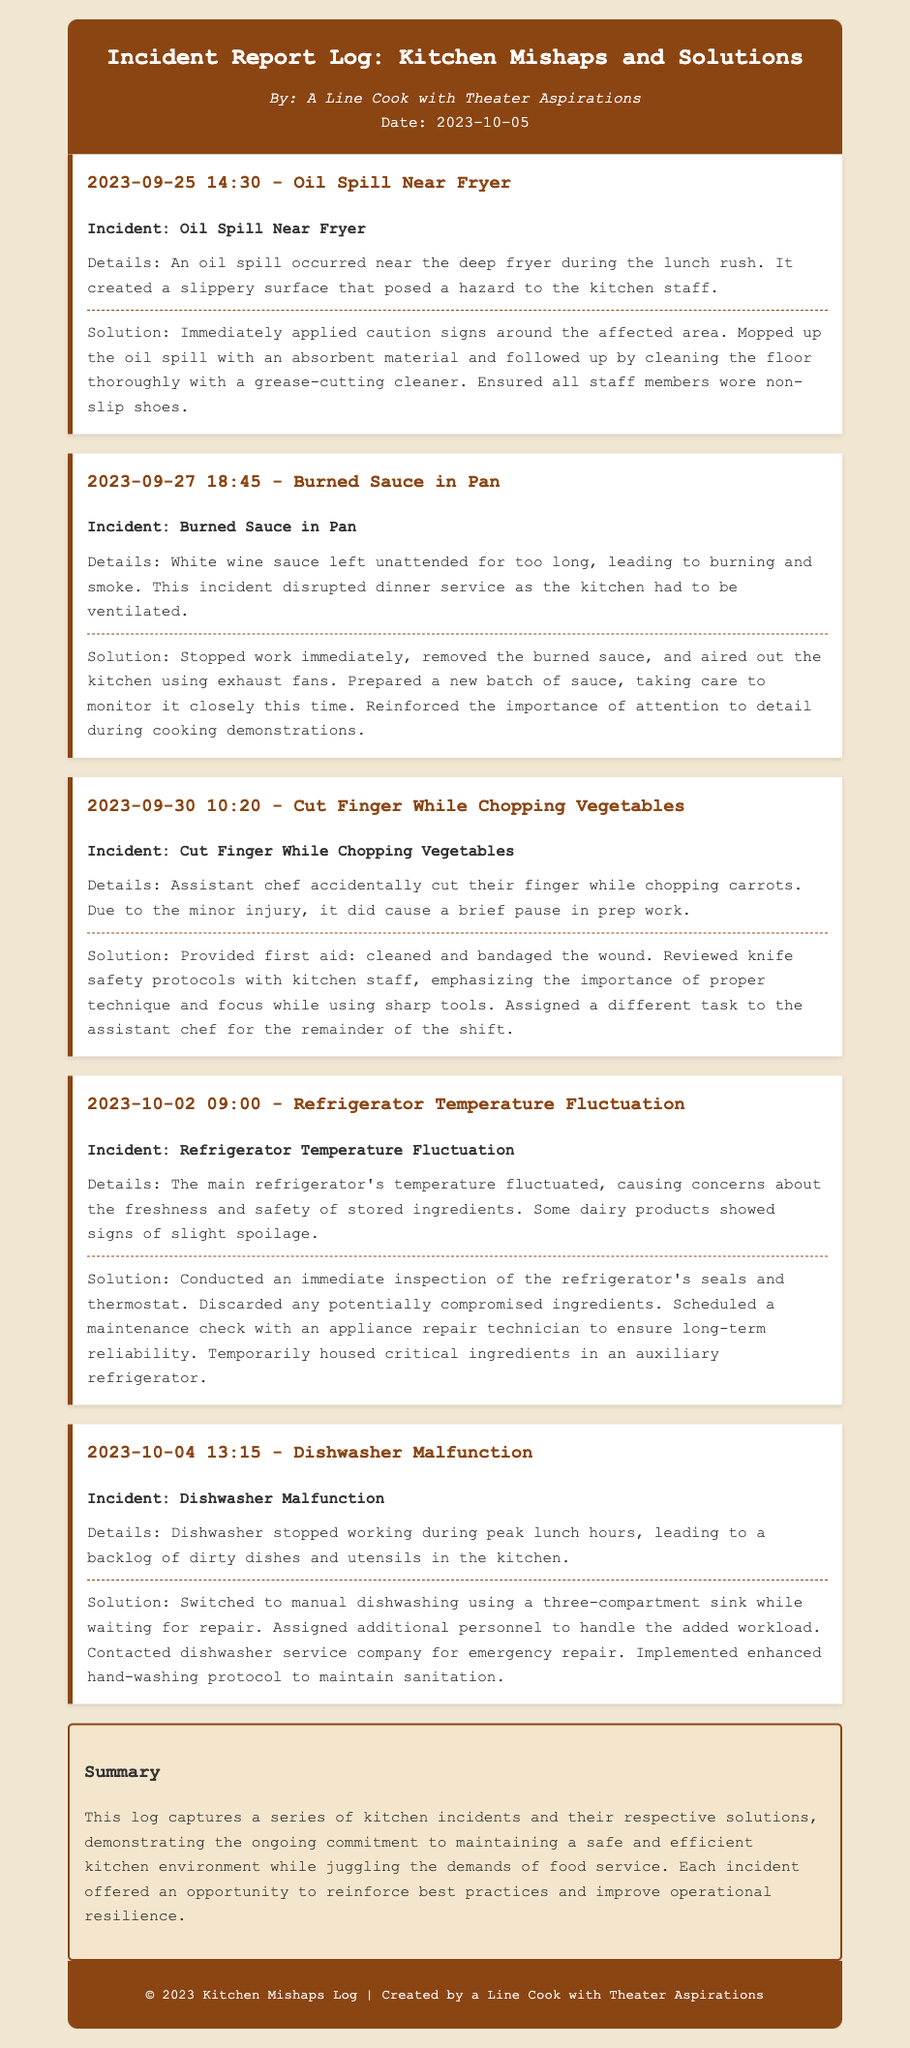What was the date of the first incident recorded? The first incident recorded in the log is dated September 25, 2023.
Answer: September 25, 2023 How many incidents are reported in total? There are five incidents logged in the document.
Answer: Five What incident caused a disruption in dinner service? The incident with the burned sauce in the pan caused a disruption during dinner service.
Answer: Burned Sauce in Pan What was the solution for the oil spill incident? The solution included applying caution signs, mopping up the oil, and ensuring staff wore non-slip shoes.
Answer: Caution signs, mopped, non-slip shoes Which kitchen appliance malfunctioned on October 4? The dishwasher malfunctioned during peak lunch hours on October 4.
Answer: Dishwasher What did the kitchen staff do during the dishwasher malfunction? They switched to manual dishwashing using a three-compartment sink.
Answer: Manual dishwashing What safety procedure was reinforced after the cut finger incident? Knife safety protocols were reinforced with the kitchen staff.
Answer: Knife safety protocols What was scheduled to check the refrigerator's reliability? A maintenance check with an appliance repair technician was scheduled.
Answer: Maintenance check 